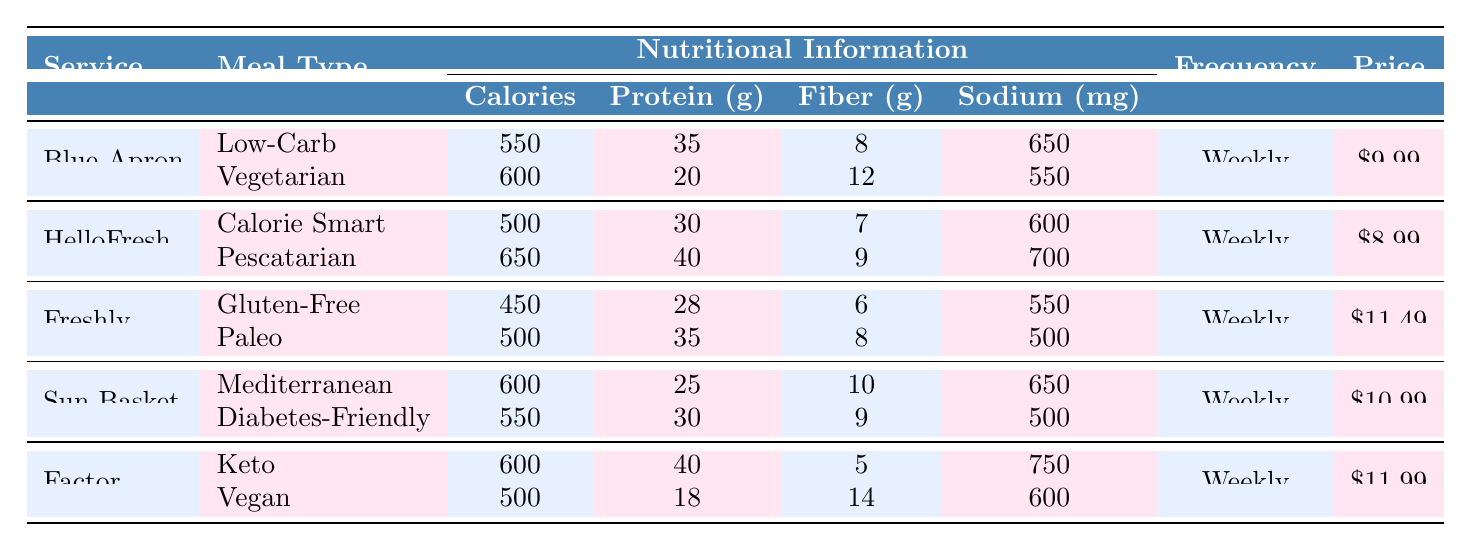What is the price per serving of HelloFresh? The table lists "HelloFresh" under the "Service" column, and the corresponding "Price" column indicates it is $8.99
Answer: $8.99 How many grams of protein are in the Low-Carb meal from Blue Apron? In the "Blue Apron" section, under the "Low-Carb" meal type, the table shows the "Average Protein" is 35 grams
Answer: 35 grams Which meal delivery service offers a meal type with the least average calories? By examining the "Average Calories" for all meal types, "Freshly" has the Gluten-Free meal with 450 calories, which is the lowest
Answer: Freshly What is the average amount of sodium in Factor meals? For the "Factor" service, the sodium content is 750 mg for the Keto meal and 600 mg for the Vegan meal. The average is (750 + 600)/2 = 675 mg
Answer: 675 mg Does Sun Basket offer a meal type that is diabetes-friendly? The table shows that one of the meal types listed under "Sun Basket" is "Diabetes-Friendly," confirming that it does offer such an option
Answer: Yes If I want a meal with the highest average fiber, which service should I choose? Looking at the "Average Fiber" values, the Vegan meal from "Factor" has 14 grams, the highest in the table, making it the best option
Answer: Factor How many total meal types does Freshly provide? The "Freshly" service offers two meal types listed in the table: Gluten-Free and Paleo
Answer: 2 Which meal type from HelloFresh has the highest average protein content? In "HelloFresh," the Pescatarian meal has 40 grams of protein, while the Calorie Smart meal has 30 grams. Therefore, Pescatarian has the highest
Answer: Pescatarian What is the average calorie count for Blue Apron's two meal types? The average calorie count is calculated as (550 + 600)/2 = 575 calories for the two meal types of Blue Apron
Answer: 575 calories What delivery frequency do all the meal delivery services have? All services listed, including Blue Apron, HelloFresh, Freshly, Sun Basket, and Factor, indicate a delivery frequency of "Weekly"
Answer: Weekly 